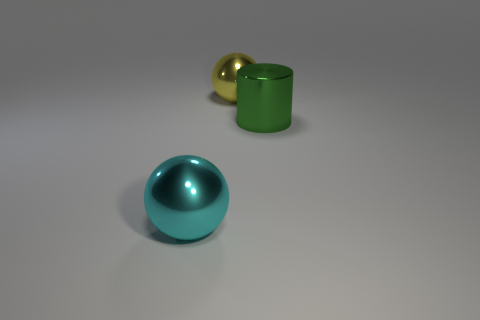What number of things are either gray matte cylinders or big cylinders?
Offer a very short reply. 1. There is a yellow metal thing behind the cyan thing; is it the same shape as the thing in front of the green object?
Your response must be concise. Yes. What is the shape of the thing behind the green metal object?
Provide a succinct answer. Sphere. Are there the same number of large metal spheres behind the green metal object and shiny objects on the right side of the yellow ball?
Offer a terse response. Yes. What number of things are either tiny red cubes or metal objects behind the large cyan object?
Offer a terse response. 2. There is a shiny object that is to the left of the green metal cylinder and behind the large cyan shiny sphere; what is its shape?
Give a very brief answer. Sphere. There is a sphere that is in front of the metallic object that is to the right of the yellow metal ball; what is it made of?
Provide a succinct answer. Metal. Do the big sphere that is in front of the cylinder and the yellow ball have the same material?
Your answer should be compact. Yes. Is there a cylinder behind the thing on the right side of the yellow shiny sphere?
Provide a short and direct response. No. The large cylinder has what color?
Make the answer very short. Green. 